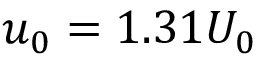Convert formula to latex. <formula><loc_0><loc_0><loc_500><loc_500>u _ { 0 } = 1 . 3 1 U _ { 0 }</formula> 